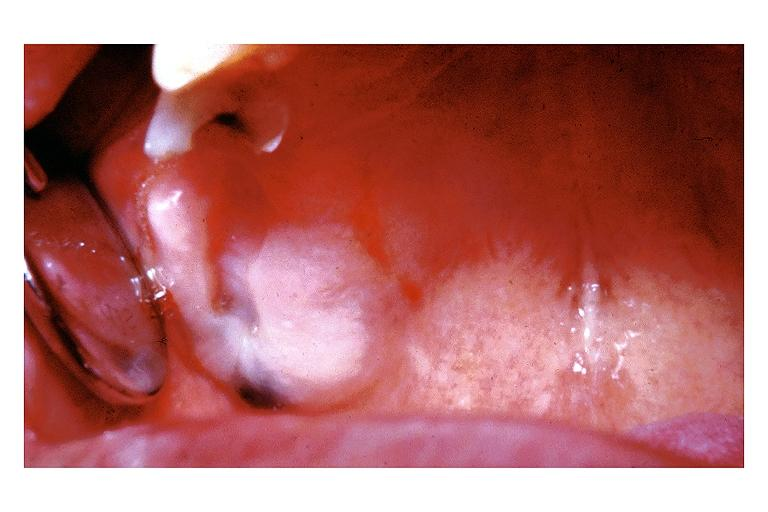s vasculitis due to rocky mountain present?
Answer the question using a single word or phrase. No 